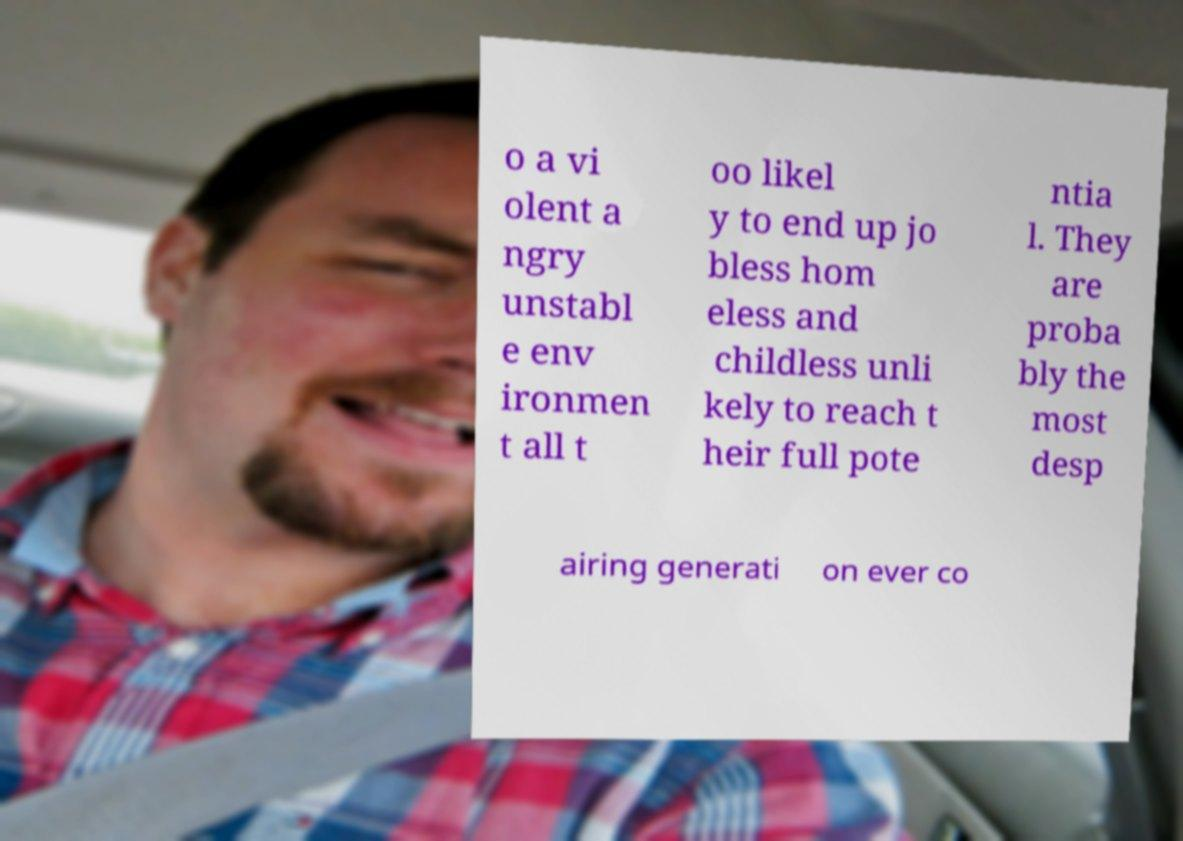Please identify and transcribe the text found in this image. o a vi olent a ngry unstabl e env ironmen t all t oo likel y to end up jo bless hom eless and childless unli kely to reach t heir full pote ntia l. They are proba bly the most desp airing generati on ever co 